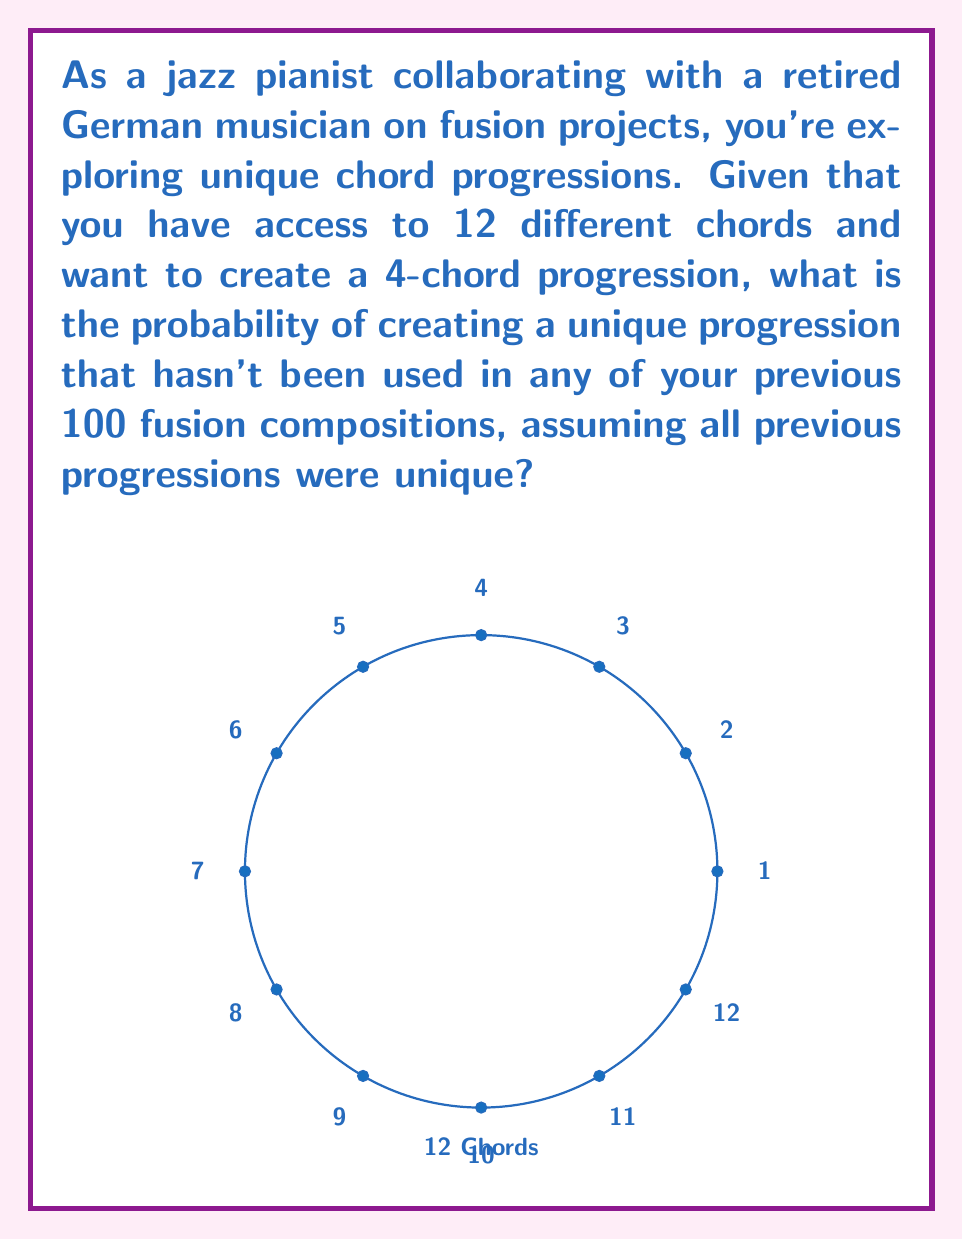Could you help me with this problem? Let's approach this step-by-step:

1) First, we need to calculate the total number of possible 4-chord progressions:
   - We have 12 chords to choose from for each position in the progression.
   - The order matters (e.g., C-F-G-Am is different from F-C-G-Am).
   - We can reuse chords (e.g., C-F-C-G is allowed).
   - This is a case of permutation with repetition.
   
   Total possible progressions = $12^4 = 20,736$

2) Now, we know that 100 of these progressions have already been used in previous compositions.

3) The number of remaining unique progressions:
   $20,736 - 100 = 20,636$

4) The probability of choosing a unique progression is:
   $$P(\text{unique}) = \frac{\text{number of favorable outcomes}}{\text{total number of possible outcomes}}$$
   $$P(\text{unique}) = \frac{20,636}{20,736}$$

5) Simplifying the fraction:
   $$P(\text{unique}) = \frac{5159}{5184} \approx 0.9952$$

Therefore, the probability of creating a unique chord progression is $\frac{5159}{5184}$ or approximately 99.52%.
Answer: $\frac{5159}{5184}$ 